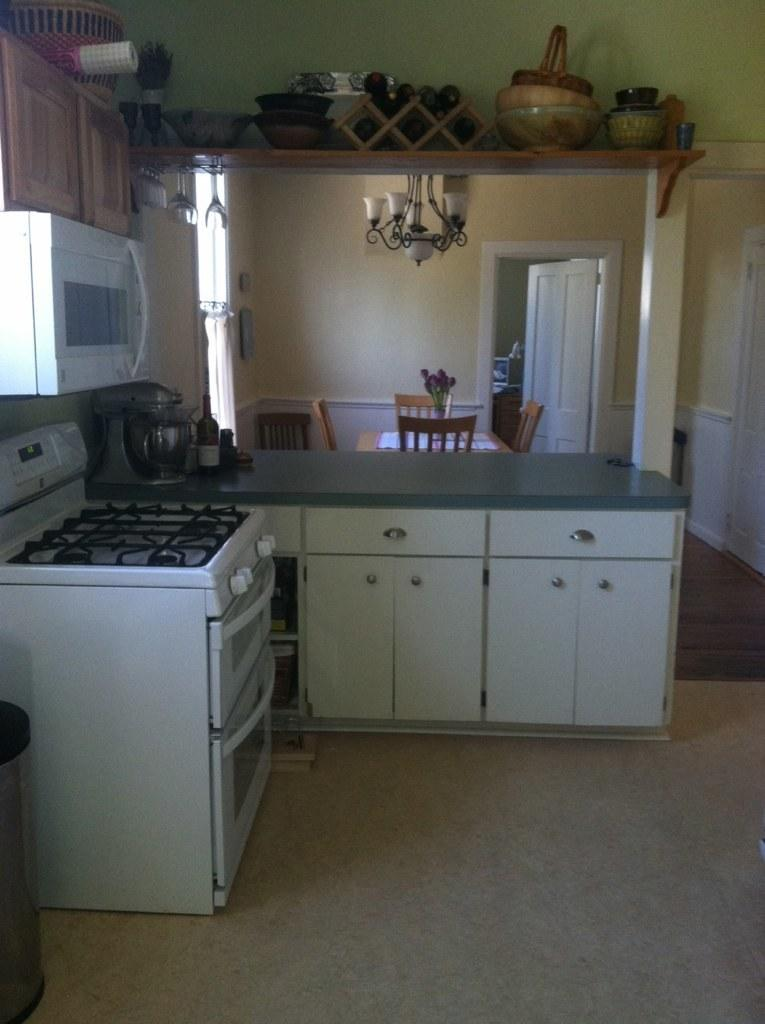What type of room is depicted in the image? The image is of a kitchen. What furniture is present in the kitchen? There is a table and a dining table in the kitchen. What appliance can be seen in the kitchen? There is a stove in the kitchen. Where are items stored in the kitchen? There are items on the shelf in the kitchen. What type of rice is being cooked on the stove in the image? There is no rice being cooked on the stove in the image. How many family members can be seen in the image? There are no family members visible in the image; it only shows a kitchen with furniture and appliances. 